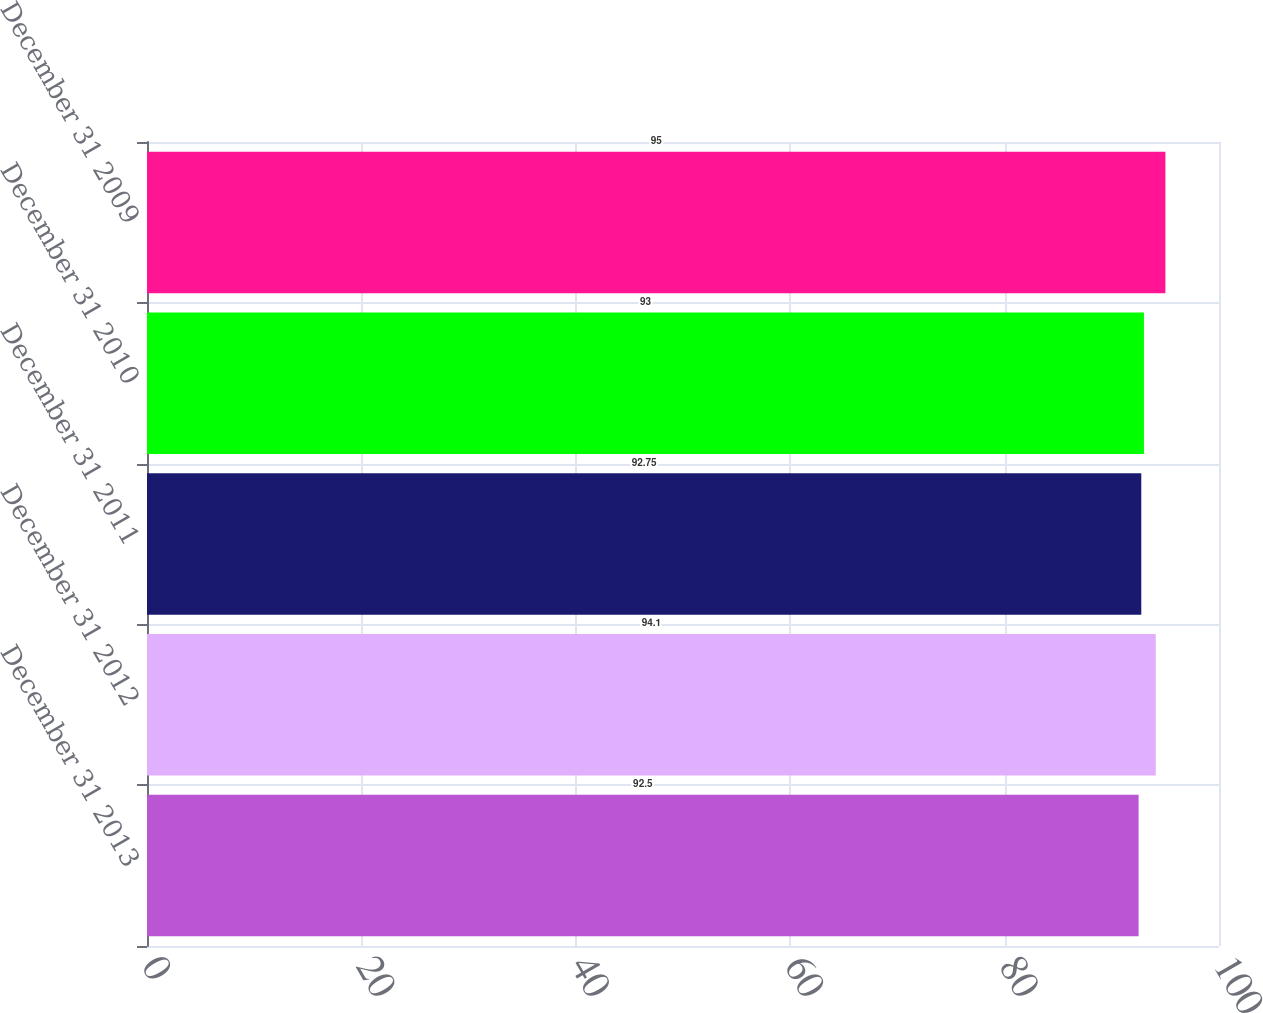<chart> <loc_0><loc_0><loc_500><loc_500><bar_chart><fcel>December 31 2013<fcel>December 31 2012<fcel>December 31 2011<fcel>December 31 2010<fcel>December 31 2009<nl><fcel>92.5<fcel>94.1<fcel>92.75<fcel>93<fcel>95<nl></chart> 